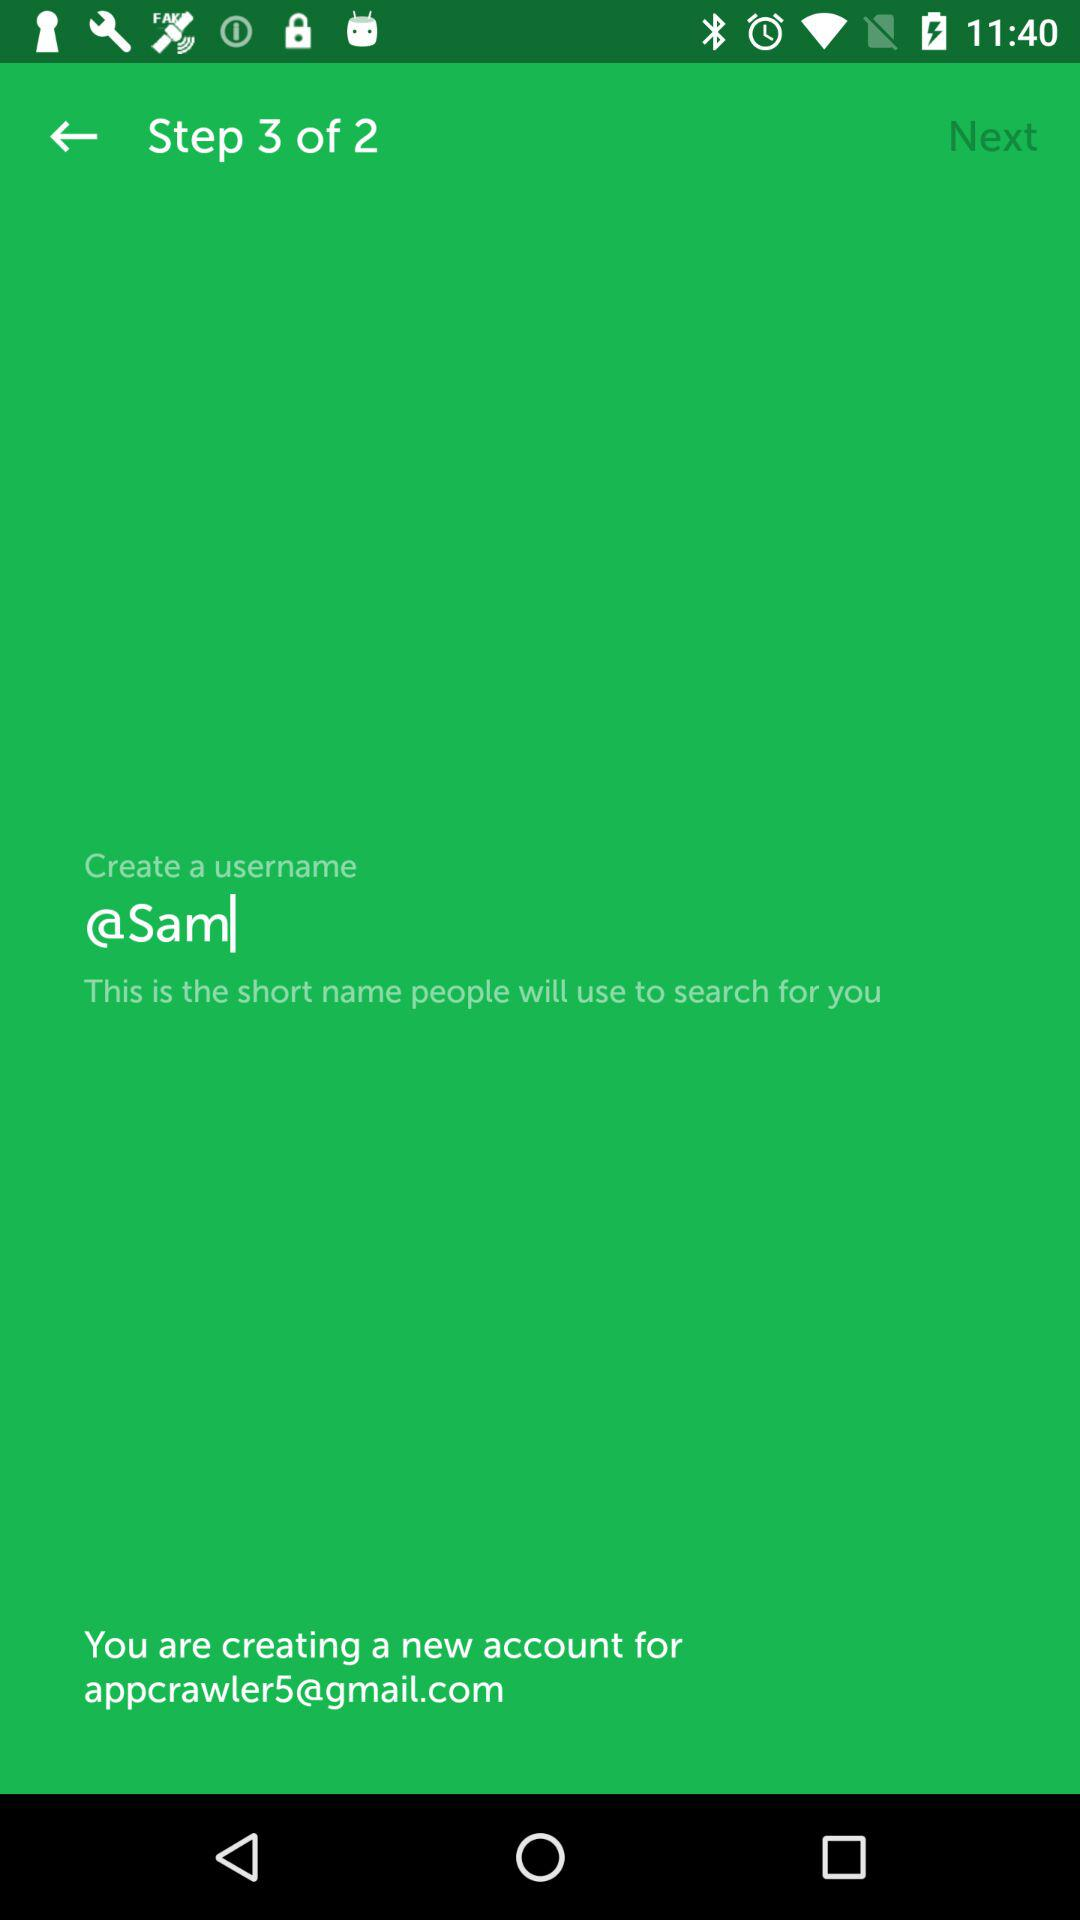What is the total number of steps? The total number of steps is 2. 